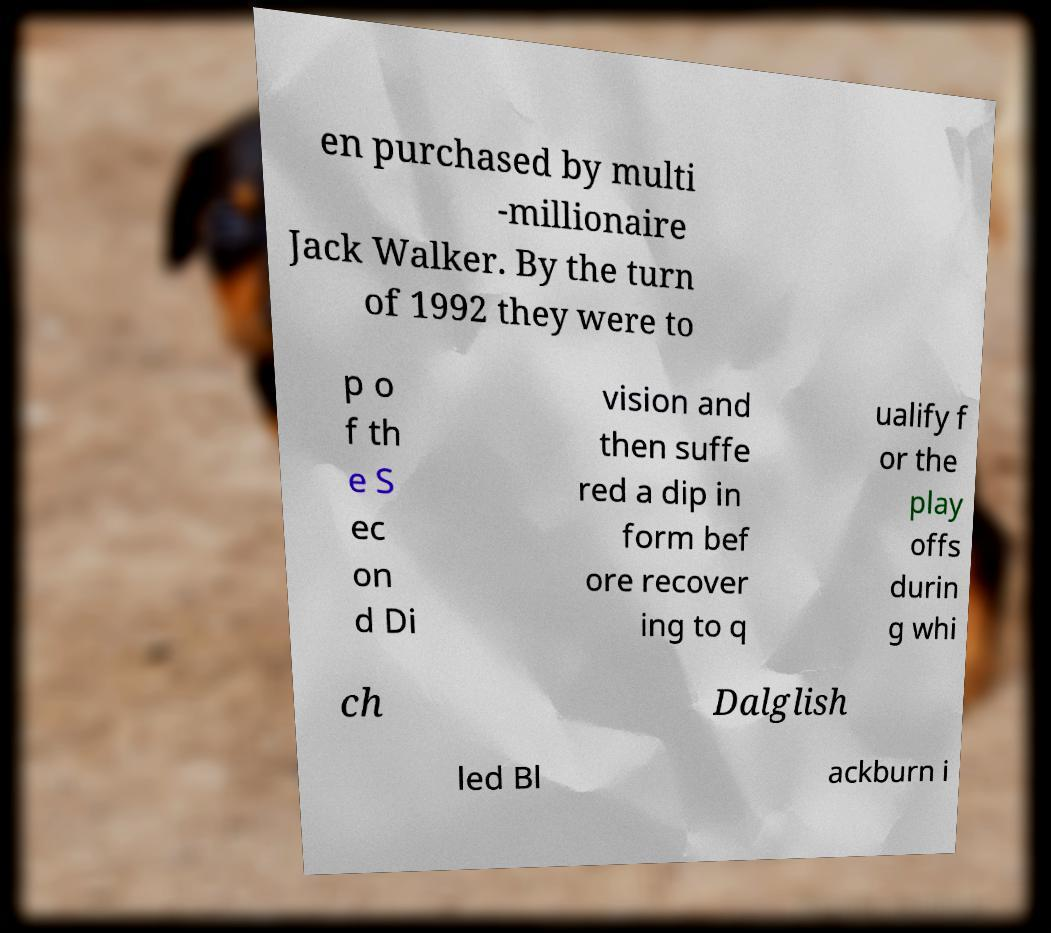Could you extract and type out the text from this image? en purchased by multi -millionaire Jack Walker. By the turn of 1992 they were to p o f th e S ec on d Di vision and then suffe red a dip in form bef ore recover ing to q ualify f or the play offs durin g whi ch Dalglish led Bl ackburn i 